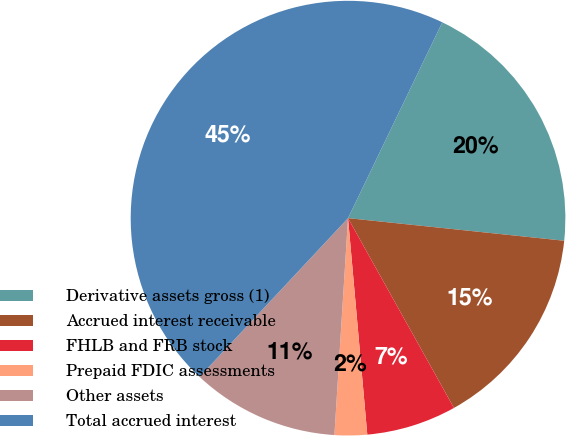<chart> <loc_0><loc_0><loc_500><loc_500><pie_chart><fcel>Derivative assets gross (1)<fcel>Accrued interest receivable<fcel>FHLB and FRB stock<fcel>Prepaid FDIC assessments<fcel>Other assets<fcel>Total accrued interest<nl><fcel>19.52%<fcel>15.24%<fcel>6.69%<fcel>2.41%<fcel>10.97%<fcel>45.17%<nl></chart> 